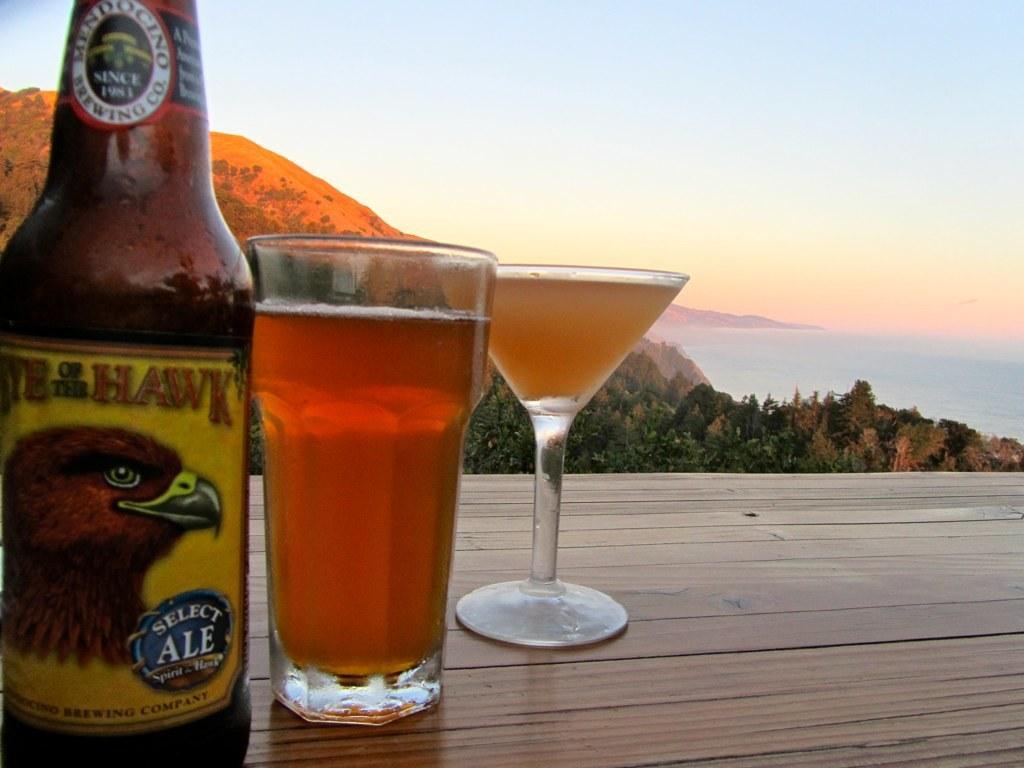Describe this image in one or two sentences. In this image I can see two glasses and a bottle on the table and I can see some liquid in the glasses. I can see trees in green color, mountains and the sky is in blue color. 